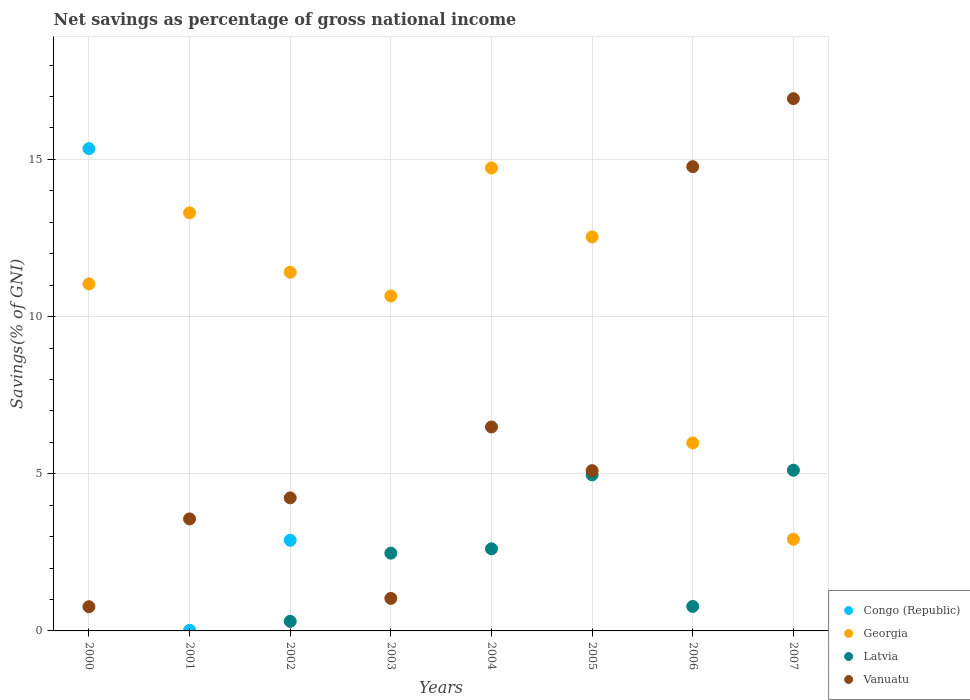What is the total savings in Georgia in 2006?
Your answer should be compact. 5.98. Across all years, what is the maximum total savings in Vanuatu?
Give a very brief answer. 16.93. Across all years, what is the minimum total savings in Georgia?
Your answer should be compact. 2.92. In which year was the total savings in Congo (Republic) maximum?
Provide a short and direct response. 2000. What is the total total savings in Vanuatu in the graph?
Provide a short and direct response. 52.89. What is the difference between the total savings in Georgia in 2000 and that in 2007?
Offer a very short reply. 8.12. What is the difference between the total savings in Vanuatu in 2002 and the total savings in Georgia in 2007?
Make the answer very short. 1.32. What is the average total savings in Congo (Republic) per year?
Your response must be concise. 2.28. In the year 2000, what is the difference between the total savings in Georgia and total savings in Vanuatu?
Offer a very short reply. 10.27. In how many years, is the total savings in Vanuatu greater than 6 %?
Offer a terse response. 3. What is the ratio of the total savings in Vanuatu in 2005 to that in 2007?
Your answer should be very brief. 0.3. Is the total savings in Vanuatu in 2002 less than that in 2007?
Your answer should be very brief. Yes. Is the difference between the total savings in Georgia in 2002 and 2005 greater than the difference between the total savings in Vanuatu in 2002 and 2005?
Offer a terse response. No. What is the difference between the highest and the second highest total savings in Georgia?
Your answer should be compact. 1.43. What is the difference between the highest and the lowest total savings in Latvia?
Give a very brief answer. 5.11. Is it the case that in every year, the sum of the total savings in Congo (Republic) and total savings in Latvia  is greater than the total savings in Georgia?
Offer a very short reply. No. Does the total savings in Congo (Republic) monotonically increase over the years?
Keep it short and to the point. No. How many years are there in the graph?
Provide a short and direct response. 8. What is the difference between two consecutive major ticks on the Y-axis?
Ensure brevity in your answer.  5. What is the title of the graph?
Give a very brief answer. Net savings as percentage of gross national income. Does "New Zealand" appear as one of the legend labels in the graph?
Provide a short and direct response. No. What is the label or title of the X-axis?
Your answer should be very brief. Years. What is the label or title of the Y-axis?
Keep it short and to the point. Savings(% of GNI). What is the Savings(% of GNI) in Congo (Republic) in 2000?
Keep it short and to the point. 15.34. What is the Savings(% of GNI) in Georgia in 2000?
Offer a terse response. 11.04. What is the Savings(% of GNI) of Latvia in 2000?
Offer a very short reply. 0. What is the Savings(% of GNI) of Vanuatu in 2000?
Give a very brief answer. 0.77. What is the Savings(% of GNI) of Congo (Republic) in 2001?
Offer a very short reply. 0.02. What is the Savings(% of GNI) of Georgia in 2001?
Offer a terse response. 13.3. What is the Savings(% of GNI) in Latvia in 2001?
Your answer should be compact. 0. What is the Savings(% of GNI) of Vanuatu in 2001?
Make the answer very short. 3.56. What is the Savings(% of GNI) of Congo (Republic) in 2002?
Ensure brevity in your answer.  2.88. What is the Savings(% of GNI) in Georgia in 2002?
Offer a terse response. 11.41. What is the Savings(% of GNI) of Latvia in 2002?
Offer a very short reply. 0.3. What is the Savings(% of GNI) of Vanuatu in 2002?
Offer a terse response. 4.23. What is the Savings(% of GNI) in Congo (Republic) in 2003?
Offer a very short reply. 0. What is the Savings(% of GNI) in Georgia in 2003?
Provide a succinct answer. 10.66. What is the Savings(% of GNI) in Latvia in 2003?
Keep it short and to the point. 2.47. What is the Savings(% of GNI) of Vanuatu in 2003?
Offer a terse response. 1.03. What is the Savings(% of GNI) in Georgia in 2004?
Provide a short and direct response. 14.73. What is the Savings(% of GNI) in Latvia in 2004?
Your answer should be very brief. 2.61. What is the Savings(% of GNI) of Vanuatu in 2004?
Provide a short and direct response. 6.49. What is the Savings(% of GNI) in Georgia in 2005?
Provide a short and direct response. 12.53. What is the Savings(% of GNI) in Latvia in 2005?
Offer a very short reply. 4.96. What is the Savings(% of GNI) in Vanuatu in 2005?
Provide a short and direct response. 5.1. What is the Savings(% of GNI) of Georgia in 2006?
Provide a short and direct response. 5.98. What is the Savings(% of GNI) in Latvia in 2006?
Your answer should be compact. 0.78. What is the Savings(% of GNI) of Vanuatu in 2006?
Offer a very short reply. 14.77. What is the Savings(% of GNI) of Georgia in 2007?
Your answer should be compact. 2.92. What is the Savings(% of GNI) in Latvia in 2007?
Your answer should be very brief. 5.11. What is the Savings(% of GNI) of Vanuatu in 2007?
Your response must be concise. 16.93. Across all years, what is the maximum Savings(% of GNI) of Congo (Republic)?
Keep it short and to the point. 15.34. Across all years, what is the maximum Savings(% of GNI) of Georgia?
Provide a short and direct response. 14.73. Across all years, what is the maximum Savings(% of GNI) of Latvia?
Ensure brevity in your answer.  5.11. Across all years, what is the maximum Savings(% of GNI) of Vanuatu?
Offer a terse response. 16.93. Across all years, what is the minimum Savings(% of GNI) of Georgia?
Keep it short and to the point. 2.92. Across all years, what is the minimum Savings(% of GNI) of Latvia?
Provide a short and direct response. 0. Across all years, what is the minimum Savings(% of GNI) of Vanuatu?
Ensure brevity in your answer.  0.77. What is the total Savings(% of GNI) in Congo (Republic) in the graph?
Keep it short and to the point. 18.25. What is the total Savings(% of GNI) in Georgia in the graph?
Keep it short and to the point. 82.57. What is the total Savings(% of GNI) in Latvia in the graph?
Ensure brevity in your answer.  16.24. What is the total Savings(% of GNI) in Vanuatu in the graph?
Your answer should be very brief. 52.89. What is the difference between the Savings(% of GNI) of Congo (Republic) in 2000 and that in 2001?
Make the answer very short. 15.32. What is the difference between the Savings(% of GNI) of Georgia in 2000 and that in 2001?
Your response must be concise. -2.26. What is the difference between the Savings(% of GNI) in Vanuatu in 2000 and that in 2001?
Your response must be concise. -2.79. What is the difference between the Savings(% of GNI) of Congo (Republic) in 2000 and that in 2002?
Your answer should be very brief. 12.46. What is the difference between the Savings(% of GNI) in Georgia in 2000 and that in 2002?
Your answer should be compact. -0.37. What is the difference between the Savings(% of GNI) in Vanuatu in 2000 and that in 2002?
Provide a short and direct response. -3.46. What is the difference between the Savings(% of GNI) of Georgia in 2000 and that in 2003?
Give a very brief answer. 0.38. What is the difference between the Savings(% of GNI) of Vanuatu in 2000 and that in 2003?
Make the answer very short. -0.27. What is the difference between the Savings(% of GNI) in Georgia in 2000 and that in 2004?
Make the answer very short. -3.69. What is the difference between the Savings(% of GNI) of Vanuatu in 2000 and that in 2004?
Ensure brevity in your answer.  -5.72. What is the difference between the Savings(% of GNI) of Georgia in 2000 and that in 2005?
Your answer should be very brief. -1.5. What is the difference between the Savings(% of GNI) in Vanuatu in 2000 and that in 2005?
Offer a very short reply. -4.33. What is the difference between the Savings(% of GNI) in Georgia in 2000 and that in 2006?
Provide a succinct answer. 5.06. What is the difference between the Savings(% of GNI) in Vanuatu in 2000 and that in 2006?
Offer a very short reply. -14. What is the difference between the Savings(% of GNI) of Georgia in 2000 and that in 2007?
Make the answer very short. 8.12. What is the difference between the Savings(% of GNI) of Vanuatu in 2000 and that in 2007?
Keep it short and to the point. -16.16. What is the difference between the Savings(% of GNI) in Congo (Republic) in 2001 and that in 2002?
Make the answer very short. -2.86. What is the difference between the Savings(% of GNI) of Georgia in 2001 and that in 2002?
Your answer should be very brief. 1.89. What is the difference between the Savings(% of GNI) in Vanuatu in 2001 and that in 2002?
Provide a short and direct response. -0.67. What is the difference between the Savings(% of GNI) of Georgia in 2001 and that in 2003?
Provide a short and direct response. 2.64. What is the difference between the Savings(% of GNI) in Vanuatu in 2001 and that in 2003?
Offer a terse response. 2.53. What is the difference between the Savings(% of GNI) in Georgia in 2001 and that in 2004?
Offer a terse response. -1.43. What is the difference between the Savings(% of GNI) of Vanuatu in 2001 and that in 2004?
Your answer should be compact. -2.92. What is the difference between the Savings(% of GNI) in Georgia in 2001 and that in 2005?
Keep it short and to the point. 0.77. What is the difference between the Savings(% of GNI) of Vanuatu in 2001 and that in 2005?
Make the answer very short. -1.54. What is the difference between the Savings(% of GNI) of Georgia in 2001 and that in 2006?
Provide a succinct answer. 7.32. What is the difference between the Savings(% of GNI) of Vanuatu in 2001 and that in 2006?
Provide a short and direct response. -11.21. What is the difference between the Savings(% of GNI) in Georgia in 2001 and that in 2007?
Your answer should be very brief. 10.38. What is the difference between the Savings(% of GNI) of Vanuatu in 2001 and that in 2007?
Your answer should be very brief. -13.37. What is the difference between the Savings(% of GNI) in Georgia in 2002 and that in 2003?
Offer a terse response. 0.76. What is the difference between the Savings(% of GNI) in Latvia in 2002 and that in 2003?
Your answer should be compact. -2.17. What is the difference between the Savings(% of GNI) in Vanuatu in 2002 and that in 2003?
Make the answer very short. 3.2. What is the difference between the Savings(% of GNI) in Georgia in 2002 and that in 2004?
Your answer should be compact. -3.32. What is the difference between the Savings(% of GNI) in Latvia in 2002 and that in 2004?
Provide a succinct answer. -2.31. What is the difference between the Savings(% of GNI) in Vanuatu in 2002 and that in 2004?
Offer a very short reply. -2.26. What is the difference between the Savings(% of GNI) of Georgia in 2002 and that in 2005?
Offer a very short reply. -1.12. What is the difference between the Savings(% of GNI) in Latvia in 2002 and that in 2005?
Ensure brevity in your answer.  -4.66. What is the difference between the Savings(% of GNI) in Vanuatu in 2002 and that in 2005?
Offer a terse response. -0.87. What is the difference between the Savings(% of GNI) of Georgia in 2002 and that in 2006?
Your answer should be very brief. 5.43. What is the difference between the Savings(% of GNI) of Latvia in 2002 and that in 2006?
Provide a succinct answer. -0.47. What is the difference between the Savings(% of GNI) of Vanuatu in 2002 and that in 2006?
Provide a short and direct response. -10.54. What is the difference between the Savings(% of GNI) of Georgia in 2002 and that in 2007?
Make the answer very short. 8.5. What is the difference between the Savings(% of GNI) of Latvia in 2002 and that in 2007?
Your answer should be compact. -4.81. What is the difference between the Savings(% of GNI) of Vanuatu in 2002 and that in 2007?
Your answer should be compact. -12.7. What is the difference between the Savings(% of GNI) of Georgia in 2003 and that in 2004?
Your response must be concise. -4.07. What is the difference between the Savings(% of GNI) of Latvia in 2003 and that in 2004?
Offer a very short reply. -0.14. What is the difference between the Savings(% of GNI) of Vanuatu in 2003 and that in 2004?
Offer a terse response. -5.45. What is the difference between the Savings(% of GNI) in Georgia in 2003 and that in 2005?
Offer a terse response. -1.88. What is the difference between the Savings(% of GNI) of Latvia in 2003 and that in 2005?
Offer a very short reply. -2.49. What is the difference between the Savings(% of GNI) in Vanuatu in 2003 and that in 2005?
Ensure brevity in your answer.  -4.06. What is the difference between the Savings(% of GNI) of Georgia in 2003 and that in 2006?
Ensure brevity in your answer.  4.68. What is the difference between the Savings(% of GNI) of Latvia in 2003 and that in 2006?
Provide a short and direct response. 1.7. What is the difference between the Savings(% of GNI) of Vanuatu in 2003 and that in 2006?
Keep it short and to the point. -13.73. What is the difference between the Savings(% of GNI) in Georgia in 2003 and that in 2007?
Make the answer very short. 7.74. What is the difference between the Savings(% of GNI) in Latvia in 2003 and that in 2007?
Your answer should be compact. -2.64. What is the difference between the Savings(% of GNI) in Vanuatu in 2003 and that in 2007?
Keep it short and to the point. -15.9. What is the difference between the Savings(% of GNI) in Georgia in 2004 and that in 2005?
Offer a terse response. 2.19. What is the difference between the Savings(% of GNI) of Latvia in 2004 and that in 2005?
Give a very brief answer. -2.35. What is the difference between the Savings(% of GNI) of Vanuatu in 2004 and that in 2005?
Ensure brevity in your answer.  1.39. What is the difference between the Savings(% of GNI) of Georgia in 2004 and that in 2006?
Your answer should be very brief. 8.75. What is the difference between the Savings(% of GNI) of Latvia in 2004 and that in 2006?
Give a very brief answer. 1.83. What is the difference between the Savings(% of GNI) in Vanuatu in 2004 and that in 2006?
Your response must be concise. -8.28. What is the difference between the Savings(% of GNI) of Georgia in 2004 and that in 2007?
Your answer should be compact. 11.81. What is the difference between the Savings(% of GNI) of Latvia in 2004 and that in 2007?
Offer a very short reply. -2.5. What is the difference between the Savings(% of GNI) of Vanuatu in 2004 and that in 2007?
Provide a succinct answer. -10.44. What is the difference between the Savings(% of GNI) of Georgia in 2005 and that in 2006?
Make the answer very short. 6.55. What is the difference between the Savings(% of GNI) in Latvia in 2005 and that in 2006?
Your answer should be very brief. 4.19. What is the difference between the Savings(% of GNI) in Vanuatu in 2005 and that in 2006?
Your answer should be compact. -9.67. What is the difference between the Savings(% of GNI) in Georgia in 2005 and that in 2007?
Offer a very short reply. 9.62. What is the difference between the Savings(% of GNI) in Latvia in 2005 and that in 2007?
Your answer should be very brief. -0.15. What is the difference between the Savings(% of GNI) in Vanuatu in 2005 and that in 2007?
Your response must be concise. -11.83. What is the difference between the Savings(% of GNI) of Georgia in 2006 and that in 2007?
Keep it short and to the point. 3.06. What is the difference between the Savings(% of GNI) of Latvia in 2006 and that in 2007?
Provide a short and direct response. -4.33. What is the difference between the Savings(% of GNI) of Vanuatu in 2006 and that in 2007?
Provide a short and direct response. -2.16. What is the difference between the Savings(% of GNI) in Congo (Republic) in 2000 and the Savings(% of GNI) in Georgia in 2001?
Your response must be concise. 2.04. What is the difference between the Savings(% of GNI) of Congo (Republic) in 2000 and the Savings(% of GNI) of Vanuatu in 2001?
Give a very brief answer. 11.78. What is the difference between the Savings(% of GNI) in Georgia in 2000 and the Savings(% of GNI) in Vanuatu in 2001?
Your response must be concise. 7.48. What is the difference between the Savings(% of GNI) of Congo (Republic) in 2000 and the Savings(% of GNI) of Georgia in 2002?
Your response must be concise. 3.93. What is the difference between the Savings(% of GNI) in Congo (Republic) in 2000 and the Savings(% of GNI) in Latvia in 2002?
Give a very brief answer. 15.04. What is the difference between the Savings(% of GNI) in Congo (Republic) in 2000 and the Savings(% of GNI) in Vanuatu in 2002?
Give a very brief answer. 11.11. What is the difference between the Savings(% of GNI) of Georgia in 2000 and the Savings(% of GNI) of Latvia in 2002?
Ensure brevity in your answer.  10.73. What is the difference between the Savings(% of GNI) in Georgia in 2000 and the Savings(% of GNI) in Vanuatu in 2002?
Provide a succinct answer. 6.81. What is the difference between the Savings(% of GNI) of Congo (Republic) in 2000 and the Savings(% of GNI) of Georgia in 2003?
Keep it short and to the point. 4.69. What is the difference between the Savings(% of GNI) of Congo (Republic) in 2000 and the Savings(% of GNI) of Latvia in 2003?
Provide a succinct answer. 12.87. What is the difference between the Savings(% of GNI) in Congo (Republic) in 2000 and the Savings(% of GNI) in Vanuatu in 2003?
Your answer should be compact. 14.31. What is the difference between the Savings(% of GNI) in Georgia in 2000 and the Savings(% of GNI) in Latvia in 2003?
Provide a succinct answer. 8.57. What is the difference between the Savings(% of GNI) of Georgia in 2000 and the Savings(% of GNI) of Vanuatu in 2003?
Make the answer very short. 10. What is the difference between the Savings(% of GNI) in Congo (Republic) in 2000 and the Savings(% of GNI) in Georgia in 2004?
Your answer should be compact. 0.61. What is the difference between the Savings(% of GNI) in Congo (Republic) in 2000 and the Savings(% of GNI) in Latvia in 2004?
Offer a very short reply. 12.73. What is the difference between the Savings(% of GNI) in Congo (Republic) in 2000 and the Savings(% of GNI) in Vanuatu in 2004?
Keep it short and to the point. 8.85. What is the difference between the Savings(% of GNI) of Georgia in 2000 and the Savings(% of GNI) of Latvia in 2004?
Your response must be concise. 8.43. What is the difference between the Savings(% of GNI) of Georgia in 2000 and the Savings(% of GNI) of Vanuatu in 2004?
Keep it short and to the point. 4.55. What is the difference between the Savings(% of GNI) in Congo (Republic) in 2000 and the Savings(% of GNI) in Georgia in 2005?
Your response must be concise. 2.81. What is the difference between the Savings(% of GNI) of Congo (Republic) in 2000 and the Savings(% of GNI) of Latvia in 2005?
Offer a terse response. 10.38. What is the difference between the Savings(% of GNI) in Congo (Republic) in 2000 and the Savings(% of GNI) in Vanuatu in 2005?
Ensure brevity in your answer.  10.24. What is the difference between the Savings(% of GNI) of Georgia in 2000 and the Savings(% of GNI) of Latvia in 2005?
Give a very brief answer. 6.08. What is the difference between the Savings(% of GNI) of Georgia in 2000 and the Savings(% of GNI) of Vanuatu in 2005?
Your answer should be very brief. 5.94. What is the difference between the Savings(% of GNI) in Congo (Republic) in 2000 and the Savings(% of GNI) in Georgia in 2006?
Your answer should be compact. 9.36. What is the difference between the Savings(% of GNI) in Congo (Republic) in 2000 and the Savings(% of GNI) in Latvia in 2006?
Make the answer very short. 14.56. What is the difference between the Savings(% of GNI) in Congo (Republic) in 2000 and the Savings(% of GNI) in Vanuatu in 2006?
Offer a very short reply. 0.57. What is the difference between the Savings(% of GNI) of Georgia in 2000 and the Savings(% of GNI) of Latvia in 2006?
Provide a short and direct response. 10.26. What is the difference between the Savings(% of GNI) of Georgia in 2000 and the Savings(% of GNI) of Vanuatu in 2006?
Ensure brevity in your answer.  -3.73. What is the difference between the Savings(% of GNI) of Congo (Republic) in 2000 and the Savings(% of GNI) of Georgia in 2007?
Your answer should be compact. 12.43. What is the difference between the Savings(% of GNI) of Congo (Republic) in 2000 and the Savings(% of GNI) of Latvia in 2007?
Your answer should be very brief. 10.23. What is the difference between the Savings(% of GNI) of Congo (Republic) in 2000 and the Savings(% of GNI) of Vanuatu in 2007?
Your response must be concise. -1.59. What is the difference between the Savings(% of GNI) in Georgia in 2000 and the Savings(% of GNI) in Latvia in 2007?
Your response must be concise. 5.93. What is the difference between the Savings(% of GNI) of Georgia in 2000 and the Savings(% of GNI) of Vanuatu in 2007?
Make the answer very short. -5.89. What is the difference between the Savings(% of GNI) in Congo (Republic) in 2001 and the Savings(% of GNI) in Georgia in 2002?
Your response must be concise. -11.39. What is the difference between the Savings(% of GNI) in Congo (Republic) in 2001 and the Savings(% of GNI) in Latvia in 2002?
Make the answer very short. -0.28. What is the difference between the Savings(% of GNI) of Congo (Republic) in 2001 and the Savings(% of GNI) of Vanuatu in 2002?
Offer a very short reply. -4.21. What is the difference between the Savings(% of GNI) of Georgia in 2001 and the Savings(% of GNI) of Latvia in 2002?
Provide a succinct answer. 13. What is the difference between the Savings(% of GNI) of Georgia in 2001 and the Savings(% of GNI) of Vanuatu in 2002?
Provide a succinct answer. 9.07. What is the difference between the Savings(% of GNI) of Congo (Republic) in 2001 and the Savings(% of GNI) of Georgia in 2003?
Keep it short and to the point. -10.64. What is the difference between the Savings(% of GNI) in Congo (Republic) in 2001 and the Savings(% of GNI) in Latvia in 2003?
Ensure brevity in your answer.  -2.45. What is the difference between the Savings(% of GNI) of Congo (Republic) in 2001 and the Savings(% of GNI) of Vanuatu in 2003?
Give a very brief answer. -1.01. What is the difference between the Savings(% of GNI) in Georgia in 2001 and the Savings(% of GNI) in Latvia in 2003?
Keep it short and to the point. 10.83. What is the difference between the Savings(% of GNI) in Georgia in 2001 and the Savings(% of GNI) in Vanuatu in 2003?
Offer a very short reply. 12.27. What is the difference between the Savings(% of GNI) in Congo (Republic) in 2001 and the Savings(% of GNI) in Georgia in 2004?
Offer a terse response. -14.71. What is the difference between the Savings(% of GNI) in Congo (Republic) in 2001 and the Savings(% of GNI) in Latvia in 2004?
Make the answer very short. -2.59. What is the difference between the Savings(% of GNI) of Congo (Republic) in 2001 and the Savings(% of GNI) of Vanuatu in 2004?
Your response must be concise. -6.47. What is the difference between the Savings(% of GNI) in Georgia in 2001 and the Savings(% of GNI) in Latvia in 2004?
Give a very brief answer. 10.69. What is the difference between the Savings(% of GNI) of Georgia in 2001 and the Savings(% of GNI) of Vanuatu in 2004?
Your answer should be compact. 6.81. What is the difference between the Savings(% of GNI) of Congo (Republic) in 2001 and the Savings(% of GNI) of Georgia in 2005?
Give a very brief answer. -12.51. What is the difference between the Savings(% of GNI) of Congo (Republic) in 2001 and the Savings(% of GNI) of Latvia in 2005?
Your answer should be compact. -4.94. What is the difference between the Savings(% of GNI) in Congo (Republic) in 2001 and the Savings(% of GNI) in Vanuatu in 2005?
Your answer should be very brief. -5.08. What is the difference between the Savings(% of GNI) in Georgia in 2001 and the Savings(% of GNI) in Latvia in 2005?
Offer a terse response. 8.34. What is the difference between the Savings(% of GNI) in Georgia in 2001 and the Savings(% of GNI) in Vanuatu in 2005?
Offer a terse response. 8.2. What is the difference between the Savings(% of GNI) of Congo (Republic) in 2001 and the Savings(% of GNI) of Georgia in 2006?
Keep it short and to the point. -5.96. What is the difference between the Savings(% of GNI) of Congo (Republic) in 2001 and the Savings(% of GNI) of Latvia in 2006?
Keep it short and to the point. -0.76. What is the difference between the Savings(% of GNI) in Congo (Republic) in 2001 and the Savings(% of GNI) in Vanuatu in 2006?
Provide a short and direct response. -14.75. What is the difference between the Savings(% of GNI) in Georgia in 2001 and the Savings(% of GNI) in Latvia in 2006?
Offer a terse response. 12.52. What is the difference between the Savings(% of GNI) of Georgia in 2001 and the Savings(% of GNI) of Vanuatu in 2006?
Offer a very short reply. -1.47. What is the difference between the Savings(% of GNI) in Congo (Republic) in 2001 and the Savings(% of GNI) in Georgia in 2007?
Provide a succinct answer. -2.9. What is the difference between the Savings(% of GNI) of Congo (Republic) in 2001 and the Savings(% of GNI) of Latvia in 2007?
Keep it short and to the point. -5.09. What is the difference between the Savings(% of GNI) of Congo (Republic) in 2001 and the Savings(% of GNI) of Vanuatu in 2007?
Provide a succinct answer. -16.91. What is the difference between the Savings(% of GNI) of Georgia in 2001 and the Savings(% of GNI) of Latvia in 2007?
Give a very brief answer. 8.19. What is the difference between the Savings(% of GNI) in Georgia in 2001 and the Savings(% of GNI) in Vanuatu in 2007?
Provide a short and direct response. -3.63. What is the difference between the Savings(% of GNI) in Congo (Republic) in 2002 and the Savings(% of GNI) in Georgia in 2003?
Provide a short and direct response. -7.77. What is the difference between the Savings(% of GNI) in Congo (Republic) in 2002 and the Savings(% of GNI) in Latvia in 2003?
Provide a short and direct response. 0.41. What is the difference between the Savings(% of GNI) in Congo (Republic) in 2002 and the Savings(% of GNI) in Vanuatu in 2003?
Make the answer very short. 1.85. What is the difference between the Savings(% of GNI) in Georgia in 2002 and the Savings(% of GNI) in Latvia in 2003?
Your response must be concise. 8.94. What is the difference between the Savings(% of GNI) in Georgia in 2002 and the Savings(% of GNI) in Vanuatu in 2003?
Your answer should be compact. 10.38. What is the difference between the Savings(% of GNI) in Latvia in 2002 and the Savings(% of GNI) in Vanuatu in 2003?
Your answer should be compact. -0.73. What is the difference between the Savings(% of GNI) of Congo (Republic) in 2002 and the Savings(% of GNI) of Georgia in 2004?
Provide a short and direct response. -11.84. What is the difference between the Savings(% of GNI) in Congo (Republic) in 2002 and the Savings(% of GNI) in Latvia in 2004?
Your answer should be very brief. 0.27. What is the difference between the Savings(% of GNI) in Congo (Republic) in 2002 and the Savings(% of GNI) in Vanuatu in 2004?
Your answer should be very brief. -3.6. What is the difference between the Savings(% of GNI) of Georgia in 2002 and the Savings(% of GNI) of Latvia in 2004?
Ensure brevity in your answer.  8.8. What is the difference between the Savings(% of GNI) of Georgia in 2002 and the Savings(% of GNI) of Vanuatu in 2004?
Offer a very short reply. 4.92. What is the difference between the Savings(% of GNI) in Latvia in 2002 and the Savings(% of GNI) in Vanuatu in 2004?
Your answer should be very brief. -6.18. What is the difference between the Savings(% of GNI) in Congo (Republic) in 2002 and the Savings(% of GNI) in Georgia in 2005?
Your answer should be compact. -9.65. What is the difference between the Savings(% of GNI) in Congo (Republic) in 2002 and the Savings(% of GNI) in Latvia in 2005?
Give a very brief answer. -2.08. What is the difference between the Savings(% of GNI) of Congo (Republic) in 2002 and the Savings(% of GNI) of Vanuatu in 2005?
Offer a very short reply. -2.22. What is the difference between the Savings(% of GNI) in Georgia in 2002 and the Savings(% of GNI) in Latvia in 2005?
Your response must be concise. 6.45. What is the difference between the Savings(% of GNI) in Georgia in 2002 and the Savings(% of GNI) in Vanuatu in 2005?
Ensure brevity in your answer.  6.31. What is the difference between the Savings(% of GNI) in Latvia in 2002 and the Savings(% of GNI) in Vanuatu in 2005?
Provide a succinct answer. -4.79. What is the difference between the Savings(% of GNI) in Congo (Republic) in 2002 and the Savings(% of GNI) in Georgia in 2006?
Provide a short and direct response. -3.1. What is the difference between the Savings(% of GNI) in Congo (Republic) in 2002 and the Savings(% of GNI) in Latvia in 2006?
Offer a terse response. 2.11. What is the difference between the Savings(% of GNI) of Congo (Republic) in 2002 and the Savings(% of GNI) of Vanuatu in 2006?
Your response must be concise. -11.89. What is the difference between the Savings(% of GNI) in Georgia in 2002 and the Savings(% of GNI) in Latvia in 2006?
Offer a terse response. 10.63. What is the difference between the Savings(% of GNI) of Georgia in 2002 and the Savings(% of GNI) of Vanuatu in 2006?
Give a very brief answer. -3.36. What is the difference between the Savings(% of GNI) in Latvia in 2002 and the Savings(% of GNI) in Vanuatu in 2006?
Give a very brief answer. -14.46. What is the difference between the Savings(% of GNI) in Congo (Republic) in 2002 and the Savings(% of GNI) in Georgia in 2007?
Your answer should be compact. -0.03. What is the difference between the Savings(% of GNI) in Congo (Republic) in 2002 and the Savings(% of GNI) in Latvia in 2007?
Offer a very short reply. -2.23. What is the difference between the Savings(% of GNI) in Congo (Republic) in 2002 and the Savings(% of GNI) in Vanuatu in 2007?
Keep it short and to the point. -14.05. What is the difference between the Savings(% of GNI) of Georgia in 2002 and the Savings(% of GNI) of Latvia in 2007?
Ensure brevity in your answer.  6.3. What is the difference between the Savings(% of GNI) of Georgia in 2002 and the Savings(% of GNI) of Vanuatu in 2007?
Your answer should be compact. -5.52. What is the difference between the Savings(% of GNI) in Latvia in 2002 and the Savings(% of GNI) in Vanuatu in 2007?
Provide a succinct answer. -16.63. What is the difference between the Savings(% of GNI) in Georgia in 2003 and the Savings(% of GNI) in Latvia in 2004?
Offer a terse response. 8.04. What is the difference between the Savings(% of GNI) of Georgia in 2003 and the Savings(% of GNI) of Vanuatu in 2004?
Your answer should be compact. 4.17. What is the difference between the Savings(% of GNI) in Latvia in 2003 and the Savings(% of GNI) in Vanuatu in 2004?
Ensure brevity in your answer.  -4.01. What is the difference between the Savings(% of GNI) in Georgia in 2003 and the Savings(% of GNI) in Latvia in 2005?
Keep it short and to the point. 5.69. What is the difference between the Savings(% of GNI) in Georgia in 2003 and the Savings(% of GNI) in Vanuatu in 2005?
Ensure brevity in your answer.  5.56. What is the difference between the Savings(% of GNI) in Latvia in 2003 and the Savings(% of GNI) in Vanuatu in 2005?
Offer a terse response. -2.63. What is the difference between the Savings(% of GNI) in Georgia in 2003 and the Savings(% of GNI) in Latvia in 2006?
Provide a short and direct response. 9.88. What is the difference between the Savings(% of GNI) in Georgia in 2003 and the Savings(% of GNI) in Vanuatu in 2006?
Provide a short and direct response. -4.11. What is the difference between the Savings(% of GNI) in Latvia in 2003 and the Savings(% of GNI) in Vanuatu in 2006?
Ensure brevity in your answer.  -12.3. What is the difference between the Savings(% of GNI) of Georgia in 2003 and the Savings(% of GNI) of Latvia in 2007?
Offer a terse response. 5.54. What is the difference between the Savings(% of GNI) in Georgia in 2003 and the Savings(% of GNI) in Vanuatu in 2007?
Provide a succinct answer. -6.28. What is the difference between the Savings(% of GNI) of Latvia in 2003 and the Savings(% of GNI) of Vanuatu in 2007?
Keep it short and to the point. -14.46. What is the difference between the Savings(% of GNI) in Georgia in 2004 and the Savings(% of GNI) in Latvia in 2005?
Offer a very short reply. 9.76. What is the difference between the Savings(% of GNI) in Georgia in 2004 and the Savings(% of GNI) in Vanuatu in 2005?
Ensure brevity in your answer.  9.63. What is the difference between the Savings(% of GNI) of Latvia in 2004 and the Savings(% of GNI) of Vanuatu in 2005?
Give a very brief answer. -2.49. What is the difference between the Savings(% of GNI) of Georgia in 2004 and the Savings(% of GNI) of Latvia in 2006?
Your response must be concise. 13.95. What is the difference between the Savings(% of GNI) in Georgia in 2004 and the Savings(% of GNI) in Vanuatu in 2006?
Ensure brevity in your answer.  -0.04. What is the difference between the Savings(% of GNI) of Latvia in 2004 and the Savings(% of GNI) of Vanuatu in 2006?
Provide a succinct answer. -12.16. What is the difference between the Savings(% of GNI) in Georgia in 2004 and the Savings(% of GNI) in Latvia in 2007?
Your answer should be very brief. 9.62. What is the difference between the Savings(% of GNI) of Georgia in 2004 and the Savings(% of GNI) of Vanuatu in 2007?
Provide a succinct answer. -2.21. What is the difference between the Savings(% of GNI) in Latvia in 2004 and the Savings(% of GNI) in Vanuatu in 2007?
Offer a terse response. -14.32. What is the difference between the Savings(% of GNI) of Georgia in 2005 and the Savings(% of GNI) of Latvia in 2006?
Your answer should be very brief. 11.76. What is the difference between the Savings(% of GNI) in Georgia in 2005 and the Savings(% of GNI) in Vanuatu in 2006?
Provide a short and direct response. -2.23. What is the difference between the Savings(% of GNI) of Latvia in 2005 and the Savings(% of GNI) of Vanuatu in 2006?
Your response must be concise. -9.81. What is the difference between the Savings(% of GNI) of Georgia in 2005 and the Savings(% of GNI) of Latvia in 2007?
Make the answer very short. 7.42. What is the difference between the Savings(% of GNI) of Georgia in 2005 and the Savings(% of GNI) of Vanuatu in 2007?
Provide a short and direct response. -4.4. What is the difference between the Savings(% of GNI) of Latvia in 2005 and the Savings(% of GNI) of Vanuatu in 2007?
Keep it short and to the point. -11.97. What is the difference between the Savings(% of GNI) of Georgia in 2006 and the Savings(% of GNI) of Latvia in 2007?
Give a very brief answer. 0.87. What is the difference between the Savings(% of GNI) of Georgia in 2006 and the Savings(% of GNI) of Vanuatu in 2007?
Your response must be concise. -10.95. What is the difference between the Savings(% of GNI) in Latvia in 2006 and the Savings(% of GNI) in Vanuatu in 2007?
Provide a short and direct response. -16.15. What is the average Savings(% of GNI) of Congo (Republic) per year?
Ensure brevity in your answer.  2.28. What is the average Savings(% of GNI) in Georgia per year?
Offer a very short reply. 10.32. What is the average Savings(% of GNI) in Latvia per year?
Ensure brevity in your answer.  2.03. What is the average Savings(% of GNI) in Vanuatu per year?
Offer a terse response. 6.61. In the year 2000, what is the difference between the Savings(% of GNI) in Congo (Republic) and Savings(% of GNI) in Georgia?
Provide a short and direct response. 4.3. In the year 2000, what is the difference between the Savings(% of GNI) of Congo (Republic) and Savings(% of GNI) of Vanuatu?
Give a very brief answer. 14.57. In the year 2000, what is the difference between the Savings(% of GNI) of Georgia and Savings(% of GNI) of Vanuatu?
Give a very brief answer. 10.27. In the year 2001, what is the difference between the Savings(% of GNI) of Congo (Republic) and Savings(% of GNI) of Georgia?
Ensure brevity in your answer.  -13.28. In the year 2001, what is the difference between the Savings(% of GNI) in Congo (Republic) and Savings(% of GNI) in Vanuatu?
Provide a short and direct response. -3.54. In the year 2001, what is the difference between the Savings(% of GNI) in Georgia and Savings(% of GNI) in Vanuatu?
Your answer should be very brief. 9.74. In the year 2002, what is the difference between the Savings(% of GNI) of Congo (Republic) and Savings(% of GNI) of Georgia?
Provide a succinct answer. -8.53. In the year 2002, what is the difference between the Savings(% of GNI) of Congo (Republic) and Savings(% of GNI) of Latvia?
Provide a short and direct response. 2.58. In the year 2002, what is the difference between the Savings(% of GNI) of Congo (Republic) and Savings(% of GNI) of Vanuatu?
Provide a succinct answer. -1.35. In the year 2002, what is the difference between the Savings(% of GNI) in Georgia and Savings(% of GNI) in Latvia?
Your answer should be compact. 11.11. In the year 2002, what is the difference between the Savings(% of GNI) of Georgia and Savings(% of GNI) of Vanuatu?
Offer a very short reply. 7.18. In the year 2002, what is the difference between the Savings(% of GNI) of Latvia and Savings(% of GNI) of Vanuatu?
Provide a short and direct response. -3.93. In the year 2003, what is the difference between the Savings(% of GNI) of Georgia and Savings(% of GNI) of Latvia?
Provide a short and direct response. 8.18. In the year 2003, what is the difference between the Savings(% of GNI) in Georgia and Savings(% of GNI) in Vanuatu?
Offer a very short reply. 9.62. In the year 2003, what is the difference between the Savings(% of GNI) in Latvia and Savings(% of GNI) in Vanuatu?
Give a very brief answer. 1.44. In the year 2004, what is the difference between the Savings(% of GNI) in Georgia and Savings(% of GNI) in Latvia?
Keep it short and to the point. 12.12. In the year 2004, what is the difference between the Savings(% of GNI) in Georgia and Savings(% of GNI) in Vanuatu?
Your response must be concise. 8.24. In the year 2004, what is the difference between the Savings(% of GNI) of Latvia and Savings(% of GNI) of Vanuatu?
Offer a very short reply. -3.88. In the year 2005, what is the difference between the Savings(% of GNI) of Georgia and Savings(% of GNI) of Latvia?
Provide a short and direct response. 7.57. In the year 2005, what is the difference between the Savings(% of GNI) in Georgia and Savings(% of GNI) in Vanuatu?
Your answer should be compact. 7.44. In the year 2005, what is the difference between the Savings(% of GNI) in Latvia and Savings(% of GNI) in Vanuatu?
Make the answer very short. -0.14. In the year 2006, what is the difference between the Savings(% of GNI) in Georgia and Savings(% of GNI) in Latvia?
Offer a very short reply. 5.2. In the year 2006, what is the difference between the Savings(% of GNI) in Georgia and Savings(% of GNI) in Vanuatu?
Your response must be concise. -8.79. In the year 2006, what is the difference between the Savings(% of GNI) of Latvia and Savings(% of GNI) of Vanuatu?
Give a very brief answer. -13.99. In the year 2007, what is the difference between the Savings(% of GNI) of Georgia and Savings(% of GNI) of Latvia?
Your answer should be very brief. -2.2. In the year 2007, what is the difference between the Savings(% of GNI) in Georgia and Savings(% of GNI) in Vanuatu?
Ensure brevity in your answer.  -14.02. In the year 2007, what is the difference between the Savings(% of GNI) in Latvia and Savings(% of GNI) in Vanuatu?
Offer a terse response. -11.82. What is the ratio of the Savings(% of GNI) in Congo (Republic) in 2000 to that in 2001?
Ensure brevity in your answer.  740.37. What is the ratio of the Savings(% of GNI) in Georgia in 2000 to that in 2001?
Make the answer very short. 0.83. What is the ratio of the Savings(% of GNI) of Vanuatu in 2000 to that in 2001?
Your answer should be very brief. 0.22. What is the ratio of the Savings(% of GNI) in Congo (Republic) in 2000 to that in 2002?
Offer a terse response. 5.32. What is the ratio of the Savings(% of GNI) of Georgia in 2000 to that in 2002?
Offer a terse response. 0.97. What is the ratio of the Savings(% of GNI) in Vanuatu in 2000 to that in 2002?
Offer a very short reply. 0.18. What is the ratio of the Savings(% of GNI) in Georgia in 2000 to that in 2003?
Keep it short and to the point. 1.04. What is the ratio of the Savings(% of GNI) in Vanuatu in 2000 to that in 2003?
Make the answer very short. 0.74. What is the ratio of the Savings(% of GNI) in Georgia in 2000 to that in 2004?
Offer a terse response. 0.75. What is the ratio of the Savings(% of GNI) in Vanuatu in 2000 to that in 2004?
Your response must be concise. 0.12. What is the ratio of the Savings(% of GNI) of Georgia in 2000 to that in 2005?
Your answer should be very brief. 0.88. What is the ratio of the Savings(% of GNI) of Vanuatu in 2000 to that in 2005?
Your answer should be compact. 0.15. What is the ratio of the Savings(% of GNI) in Georgia in 2000 to that in 2006?
Give a very brief answer. 1.85. What is the ratio of the Savings(% of GNI) in Vanuatu in 2000 to that in 2006?
Keep it short and to the point. 0.05. What is the ratio of the Savings(% of GNI) of Georgia in 2000 to that in 2007?
Your answer should be very brief. 3.79. What is the ratio of the Savings(% of GNI) in Vanuatu in 2000 to that in 2007?
Give a very brief answer. 0.05. What is the ratio of the Savings(% of GNI) of Congo (Republic) in 2001 to that in 2002?
Your answer should be compact. 0.01. What is the ratio of the Savings(% of GNI) in Georgia in 2001 to that in 2002?
Ensure brevity in your answer.  1.17. What is the ratio of the Savings(% of GNI) in Vanuatu in 2001 to that in 2002?
Ensure brevity in your answer.  0.84. What is the ratio of the Savings(% of GNI) in Georgia in 2001 to that in 2003?
Your answer should be compact. 1.25. What is the ratio of the Savings(% of GNI) in Vanuatu in 2001 to that in 2003?
Your answer should be compact. 3.44. What is the ratio of the Savings(% of GNI) of Georgia in 2001 to that in 2004?
Make the answer very short. 0.9. What is the ratio of the Savings(% of GNI) of Vanuatu in 2001 to that in 2004?
Provide a short and direct response. 0.55. What is the ratio of the Savings(% of GNI) in Georgia in 2001 to that in 2005?
Ensure brevity in your answer.  1.06. What is the ratio of the Savings(% of GNI) in Vanuatu in 2001 to that in 2005?
Ensure brevity in your answer.  0.7. What is the ratio of the Savings(% of GNI) in Georgia in 2001 to that in 2006?
Keep it short and to the point. 2.22. What is the ratio of the Savings(% of GNI) of Vanuatu in 2001 to that in 2006?
Offer a terse response. 0.24. What is the ratio of the Savings(% of GNI) of Georgia in 2001 to that in 2007?
Give a very brief answer. 4.56. What is the ratio of the Savings(% of GNI) of Vanuatu in 2001 to that in 2007?
Your response must be concise. 0.21. What is the ratio of the Savings(% of GNI) in Georgia in 2002 to that in 2003?
Your answer should be very brief. 1.07. What is the ratio of the Savings(% of GNI) in Latvia in 2002 to that in 2003?
Your response must be concise. 0.12. What is the ratio of the Savings(% of GNI) of Vanuatu in 2002 to that in 2003?
Your answer should be very brief. 4.09. What is the ratio of the Savings(% of GNI) in Georgia in 2002 to that in 2004?
Your answer should be very brief. 0.77. What is the ratio of the Savings(% of GNI) of Latvia in 2002 to that in 2004?
Your answer should be compact. 0.12. What is the ratio of the Savings(% of GNI) of Vanuatu in 2002 to that in 2004?
Your answer should be compact. 0.65. What is the ratio of the Savings(% of GNI) of Georgia in 2002 to that in 2005?
Offer a very short reply. 0.91. What is the ratio of the Savings(% of GNI) of Latvia in 2002 to that in 2005?
Provide a short and direct response. 0.06. What is the ratio of the Savings(% of GNI) in Vanuatu in 2002 to that in 2005?
Your answer should be very brief. 0.83. What is the ratio of the Savings(% of GNI) of Georgia in 2002 to that in 2006?
Make the answer very short. 1.91. What is the ratio of the Savings(% of GNI) in Latvia in 2002 to that in 2006?
Give a very brief answer. 0.39. What is the ratio of the Savings(% of GNI) in Vanuatu in 2002 to that in 2006?
Your response must be concise. 0.29. What is the ratio of the Savings(% of GNI) in Georgia in 2002 to that in 2007?
Offer a very short reply. 3.91. What is the ratio of the Savings(% of GNI) in Latvia in 2002 to that in 2007?
Offer a terse response. 0.06. What is the ratio of the Savings(% of GNI) of Vanuatu in 2002 to that in 2007?
Give a very brief answer. 0.25. What is the ratio of the Savings(% of GNI) of Georgia in 2003 to that in 2004?
Your answer should be compact. 0.72. What is the ratio of the Savings(% of GNI) of Latvia in 2003 to that in 2004?
Provide a short and direct response. 0.95. What is the ratio of the Savings(% of GNI) of Vanuatu in 2003 to that in 2004?
Make the answer very short. 0.16. What is the ratio of the Savings(% of GNI) in Georgia in 2003 to that in 2005?
Keep it short and to the point. 0.85. What is the ratio of the Savings(% of GNI) of Latvia in 2003 to that in 2005?
Your response must be concise. 0.5. What is the ratio of the Savings(% of GNI) in Vanuatu in 2003 to that in 2005?
Provide a short and direct response. 0.2. What is the ratio of the Savings(% of GNI) in Georgia in 2003 to that in 2006?
Provide a short and direct response. 1.78. What is the ratio of the Savings(% of GNI) in Latvia in 2003 to that in 2006?
Provide a succinct answer. 3.18. What is the ratio of the Savings(% of GNI) of Vanuatu in 2003 to that in 2006?
Your answer should be compact. 0.07. What is the ratio of the Savings(% of GNI) in Georgia in 2003 to that in 2007?
Make the answer very short. 3.65. What is the ratio of the Savings(% of GNI) of Latvia in 2003 to that in 2007?
Ensure brevity in your answer.  0.48. What is the ratio of the Savings(% of GNI) of Vanuatu in 2003 to that in 2007?
Provide a short and direct response. 0.06. What is the ratio of the Savings(% of GNI) in Georgia in 2004 to that in 2005?
Your answer should be very brief. 1.17. What is the ratio of the Savings(% of GNI) in Latvia in 2004 to that in 2005?
Your response must be concise. 0.53. What is the ratio of the Savings(% of GNI) in Vanuatu in 2004 to that in 2005?
Offer a terse response. 1.27. What is the ratio of the Savings(% of GNI) in Georgia in 2004 to that in 2006?
Your answer should be very brief. 2.46. What is the ratio of the Savings(% of GNI) of Latvia in 2004 to that in 2006?
Your answer should be very brief. 3.35. What is the ratio of the Savings(% of GNI) of Vanuatu in 2004 to that in 2006?
Your response must be concise. 0.44. What is the ratio of the Savings(% of GNI) of Georgia in 2004 to that in 2007?
Offer a very short reply. 5.05. What is the ratio of the Savings(% of GNI) in Latvia in 2004 to that in 2007?
Provide a short and direct response. 0.51. What is the ratio of the Savings(% of GNI) of Vanuatu in 2004 to that in 2007?
Keep it short and to the point. 0.38. What is the ratio of the Savings(% of GNI) in Georgia in 2005 to that in 2006?
Your answer should be very brief. 2.1. What is the ratio of the Savings(% of GNI) of Latvia in 2005 to that in 2006?
Your answer should be compact. 6.38. What is the ratio of the Savings(% of GNI) in Vanuatu in 2005 to that in 2006?
Ensure brevity in your answer.  0.35. What is the ratio of the Savings(% of GNI) in Georgia in 2005 to that in 2007?
Your answer should be compact. 4.3. What is the ratio of the Savings(% of GNI) of Vanuatu in 2005 to that in 2007?
Offer a very short reply. 0.3. What is the ratio of the Savings(% of GNI) of Georgia in 2006 to that in 2007?
Offer a terse response. 2.05. What is the ratio of the Savings(% of GNI) of Latvia in 2006 to that in 2007?
Keep it short and to the point. 0.15. What is the ratio of the Savings(% of GNI) of Vanuatu in 2006 to that in 2007?
Provide a succinct answer. 0.87. What is the difference between the highest and the second highest Savings(% of GNI) of Congo (Republic)?
Ensure brevity in your answer.  12.46. What is the difference between the highest and the second highest Savings(% of GNI) of Georgia?
Provide a succinct answer. 1.43. What is the difference between the highest and the second highest Savings(% of GNI) in Latvia?
Make the answer very short. 0.15. What is the difference between the highest and the second highest Savings(% of GNI) in Vanuatu?
Your answer should be compact. 2.16. What is the difference between the highest and the lowest Savings(% of GNI) of Congo (Republic)?
Provide a short and direct response. 15.34. What is the difference between the highest and the lowest Savings(% of GNI) of Georgia?
Ensure brevity in your answer.  11.81. What is the difference between the highest and the lowest Savings(% of GNI) of Latvia?
Offer a very short reply. 5.11. What is the difference between the highest and the lowest Savings(% of GNI) of Vanuatu?
Provide a succinct answer. 16.16. 